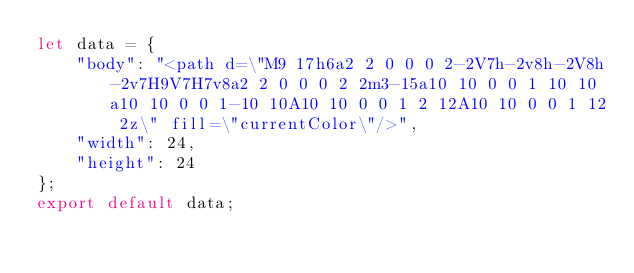Convert code to text. <code><loc_0><loc_0><loc_500><loc_500><_JavaScript_>let data = {
	"body": "<path d=\"M9 17h6a2 2 0 0 0 2-2V7h-2v8h-2V8h-2v7H9V7H7v8a2 2 0 0 0 2 2m3-15a10 10 0 0 1 10 10a10 10 0 0 1-10 10A10 10 0 0 1 2 12A10 10 0 0 1 12 2z\" fill=\"currentColor\"/>",
	"width": 24,
	"height": 24
};
export default data;
</code> 